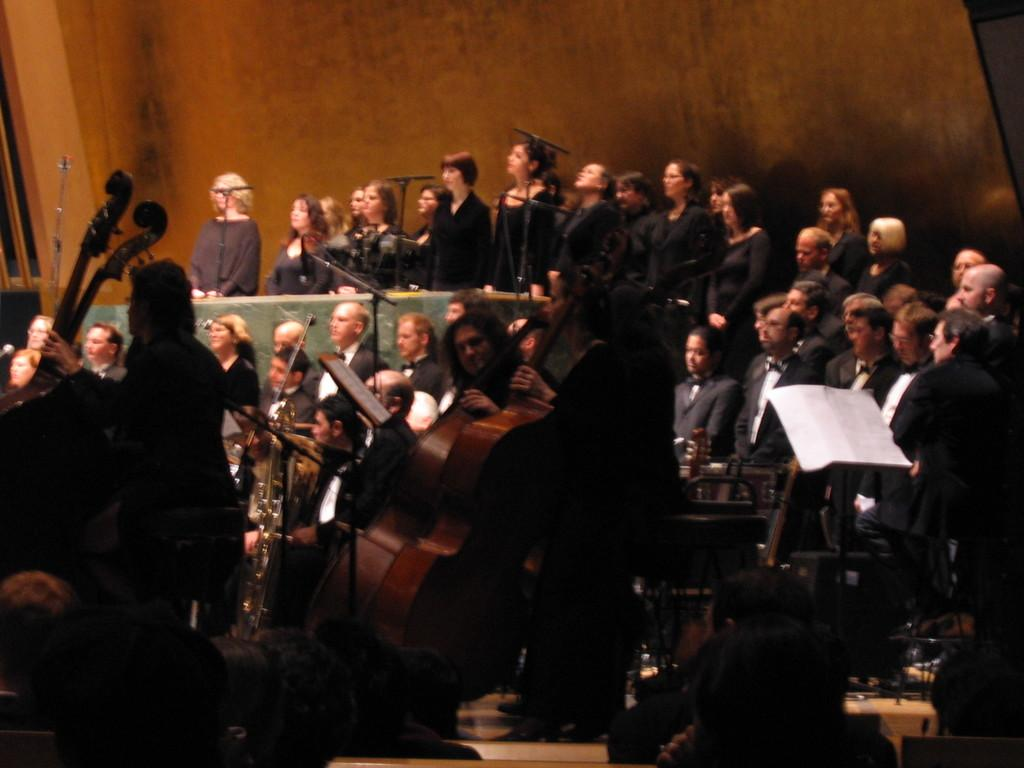What type of wall can be seen in the background of the image? There is a wooden wall in the background of the image. What are the people in the image doing? Some people are playing musical instruments. Can you describe the paper visible in the image? There is a white paper on the right side of the image. What type of development is taking place in the image? There is no development project or activity visible in the image. Can you see a spoon in the image? There is no spoon present in the image. 